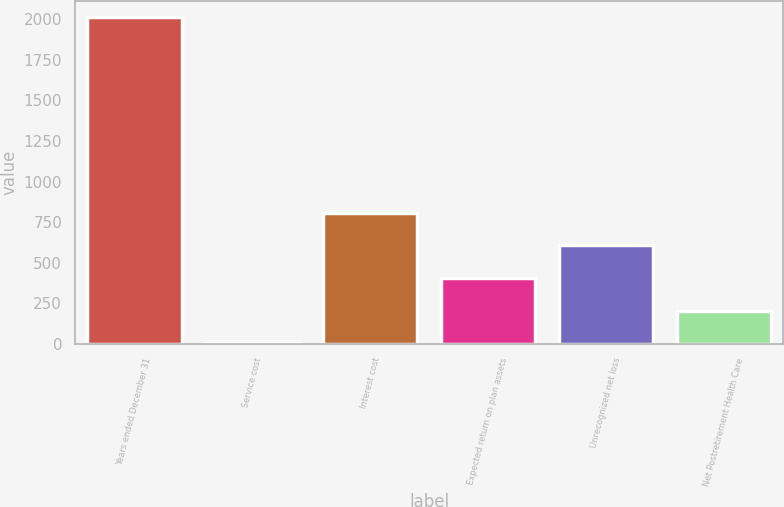Convert chart to OTSL. <chart><loc_0><loc_0><loc_500><loc_500><bar_chart><fcel>Years ended December 31<fcel>Service cost<fcel>Interest cost<fcel>Expected return on plan assets<fcel>Unrecognized net loss<fcel>Net Postretirement Health Care<nl><fcel>2012<fcel>3<fcel>806.6<fcel>404.8<fcel>605.7<fcel>203.9<nl></chart> 